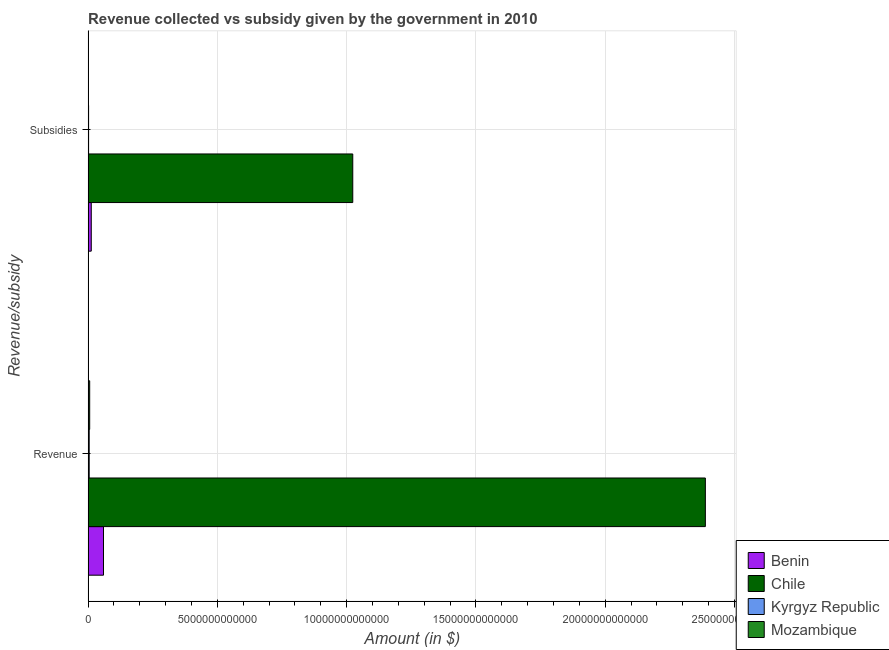How many different coloured bars are there?
Offer a very short reply. 4. How many groups of bars are there?
Keep it short and to the point. 2. Are the number of bars per tick equal to the number of legend labels?
Make the answer very short. Yes. Are the number of bars on each tick of the Y-axis equal?
Offer a very short reply. Yes. What is the label of the 1st group of bars from the top?
Your response must be concise. Subsidies. What is the amount of subsidies given in Kyrgyz Republic?
Give a very brief answer. 1.94e+1. Across all countries, what is the maximum amount of subsidies given?
Ensure brevity in your answer.  1.02e+13. Across all countries, what is the minimum amount of revenue collected?
Ensure brevity in your answer.  4.28e+1. In which country was the amount of revenue collected minimum?
Your answer should be very brief. Kyrgyz Republic. What is the total amount of revenue collected in the graph?
Make the answer very short. 2.46e+13. What is the difference between the amount of revenue collected in Chile and that in Mozambique?
Make the answer very short. 2.38e+13. What is the difference between the amount of revenue collected in Kyrgyz Republic and the amount of subsidies given in Benin?
Provide a succinct answer. -8.03e+1. What is the average amount of revenue collected per country?
Offer a terse response. 6.14e+12. What is the difference between the amount of subsidies given and amount of revenue collected in Benin?
Your response must be concise. -4.73e+11. What is the ratio of the amount of subsidies given in Chile to that in Mozambique?
Your response must be concise. 718.87. Is the amount of subsidies given in Kyrgyz Republic less than that in Chile?
Offer a very short reply. Yes. What does the 4th bar from the top in Revenue represents?
Give a very brief answer. Benin. What does the 2nd bar from the bottom in Revenue represents?
Give a very brief answer. Chile. How many countries are there in the graph?
Your answer should be compact. 4. What is the difference between two consecutive major ticks on the X-axis?
Offer a terse response. 5.00e+12. Does the graph contain any zero values?
Give a very brief answer. No. Does the graph contain grids?
Provide a short and direct response. Yes. How many legend labels are there?
Your response must be concise. 4. How are the legend labels stacked?
Provide a succinct answer. Vertical. What is the title of the graph?
Keep it short and to the point. Revenue collected vs subsidy given by the government in 2010. What is the label or title of the X-axis?
Your answer should be very brief. Amount (in $). What is the label or title of the Y-axis?
Ensure brevity in your answer.  Revenue/subsidy. What is the Amount (in $) in Benin in Revenue?
Your response must be concise. 5.96e+11. What is the Amount (in $) in Chile in Revenue?
Offer a terse response. 2.39e+13. What is the Amount (in $) of Kyrgyz Republic in Revenue?
Keep it short and to the point. 4.28e+1. What is the Amount (in $) of Mozambique in Revenue?
Keep it short and to the point. 6.17e+1. What is the Amount (in $) of Benin in Subsidies?
Make the answer very short. 1.23e+11. What is the Amount (in $) of Chile in Subsidies?
Provide a short and direct response. 1.02e+13. What is the Amount (in $) in Kyrgyz Republic in Subsidies?
Your answer should be very brief. 1.94e+1. What is the Amount (in $) in Mozambique in Subsidies?
Keep it short and to the point. 1.42e+1. Across all Revenue/subsidy, what is the maximum Amount (in $) in Benin?
Provide a short and direct response. 5.96e+11. Across all Revenue/subsidy, what is the maximum Amount (in $) in Chile?
Keep it short and to the point. 2.39e+13. Across all Revenue/subsidy, what is the maximum Amount (in $) in Kyrgyz Republic?
Make the answer very short. 4.28e+1. Across all Revenue/subsidy, what is the maximum Amount (in $) in Mozambique?
Provide a succinct answer. 6.17e+1. Across all Revenue/subsidy, what is the minimum Amount (in $) in Benin?
Ensure brevity in your answer.  1.23e+11. Across all Revenue/subsidy, what is the minimum Amount (in $) of Chile?
Keep it short and to the point. 1.02e+13. Across all Revenue/subsidy, what is the minimum Amount (in $) in Kyrgyz Republic?
Give a very brief answer. 1.94e+1. Across all Revenue/subsidy, what is the minimum Amount (in $) of Mozambique?
Provide a succinct answer. 1.42e+1. What is the total Amount (in $) of Benin in the graph?
Ensure brevity in your answer.  7.19e+11. What is the total Amount (in $) of Chile in the graph?
Ensure brevity in your answer.  3.41e+13. What is the total Amount (in $) in Kyrgyz Republic in the graph?
Make the answer very short. 6.22e+1. What is the total Amount (in $) in Mozambique in the graph?
Make the answer very short. 7.59e+1. What is the difference between the Amount (in $) of Benin in Revenue and that in Subsidies?
Give a very brief answer. 4.73e+11. What is the difference between the Amount (in $) in Chile in Revenue and that in Subsidies?
Your answer should be compact. 1.36e+13. What is the difference between the Amount (in $) in Kyrgyz Republic in Revenue and that in Subsidies?
Provide a succinct answer. 2.34e+1. What is the difference between the Amount (in $) in Mozambique in Revenue and that in Subsidies?
Keep it short and to the point. 4.75e+1. What is the difference between the Amount (in $) in Benin in Revenue and the Amount (in $) in Chile in Subsidies?
Your answer should be very brief. -9.64e+12. What is the difference between the Amount (in $) in Benin in Revenue and the Amount (in $) in Kyrgyz Republic in Subsidies?
Provide a short and direct response. 5.77e+11. What is the difference between the Amount (in $) of Benin in Revenue and the Amount (in $) of Mozambique in Subsidies?
Your answer should be very brief. 5.82e+11. What is the difference between the Amount (in $) of Chile in Revenue and the Amount (in $) of Kyrgyz Republic in Subsidies?
Provide a short and direct response. 2.39e+13. What is the difference between the Amount (in $) of Chile in Revenue and the Amount (in $) of Mozambique in Subsidies?
Make the answer very short. 2.39e+13. What is the difference between the Amount (in $) in Kyrgyz Republic in Revenue and the Amount (in $) in Mozambique in Subsidies?
Keep it short and to the point. 2.86e+1. What is the average Amount (in $) in Benin per Revenue/subsidy?
Give a very brief answer. 3.60e+11. What is the average Amount (in $) in Chile per Revenue/subsidy?
Ensure brevity in your answer.  1.71e+13. What is the average Amount (in $) of Kyrgyz Republic per Revenue/subsidy?
Give a very brief answer. 3.11e+1. What is the average Amount (in $) of Mozambique per Revenue/subsidy?
Ensure brevity in your answer.  3.80e+1. What is the difference between the Amount (in $) in Benin and Amount (in $) in Chile in Revenue?
Ensure brevity in your answer.  -2.33e+13. What is the difference between the Amount (in $) in Benin and Amount (in $) in Kyrgyz Republic in Revenue?
Provide a succinct answer. 5.53e+11. What is the difference between the Amount (in $) of Benin and Amount (in $) of Mozambique in Revenue?
Your response must be concise. 5.34e+11. What is the difference between the Amount (in $) in Chile and Amount (in $) in Kyrgyz Republic in Revenue?
Keep it short and to the point. 2.38e+13. What is the difference between the Amount (in $) of Chile and Amount (in $) of Mozambique in Revenue?
Provide a succinct answer. 2.38e+13. What is the difference between the Amount (in $) in Kyrgyz Republic and Amount (in $) in Mozambique in Revenue?
Ensure brevity in your answer.  -1.89e+1. What is the difference between the Amount (in $) of Benin and Amount (in $) of Chile in Subsidies?
Provide a succinct answer. -1.01e+13. What is the difference between the Amount (in $) in Benin and Amount (in $) in Kyrgyz Republic in Subsidies?
Your answer should be compact. 1.04e+11. What is the difference between the Amount (in $) in Benin and Amount (in $) in Mozambique in Subsidies?
Give a very brief answer. 1.09e+11. What is the difference between the Amount (in $) in Chile and Amount (in $) in Kyrgyz Republic in Subsidies?
Give a very brief answer. 1.02e+13. What is the difference between the Amount (in $) in Chile and Amount (in $) in Mozambique in Subsidies?
Give a very brief answer. 1.02e+13. What is the difference between the Amount (in $) in Kyrgyz Republic and Amount (in $) in Mozambique in Subsidies?
Keep it short and to the point. 5.14e+09. What is the ratio of the Amount (in $) in Benin in Revenue to that in Subsidies?
Provide a short and direct response. 4.84. What is the ratio of the Amount (in $) of Chile in Revenue to that in Subsidies?
Your answer should be compact. 2.33. What is the ratio of the Amount (in $) of Kyrgyz Republic in Revenue to that in Subsidies?
Keep it short and to the point. 2.21. What is the ratio of the Amount (in $) of Mozambique in Revenue to that in Subsidies?
Your response must be concise. 4.33. What is the difference between the highest and the second highest Amount (in $) of Benin?
Make the answer very short. 4.73e+11. What is the difference between the highest and the second highest Amount (in $) of Chile?
Give a very brief answer. 1.36e+13. What is the difference between the highest and the second highest Amount (in $) in Kyrgyz Republic?
Keep it short and to the point. 2.34e+1. What is the difference between the highest and the second highest Amount (in $) of Mozambique?
Keep it short and to the point. 4.75e+1. What is the difference between the highest and the lowest Amount (in $) of Benin?
Your answer should be very brief. 4.73e+11. What is the difference between the highest and the lowest Amount (in $) in Chile?
Your response must be concise. 1.36e+13. What is the difference between the highest and the lowest Amount (in $) of Kyrgyz Republic?
Keep it short and to the point. 2.34e+1. What is the difference between the highest and the lowest Amount (in $) in Mozambique?
Keep it short and to the point. 4.75e+1. 